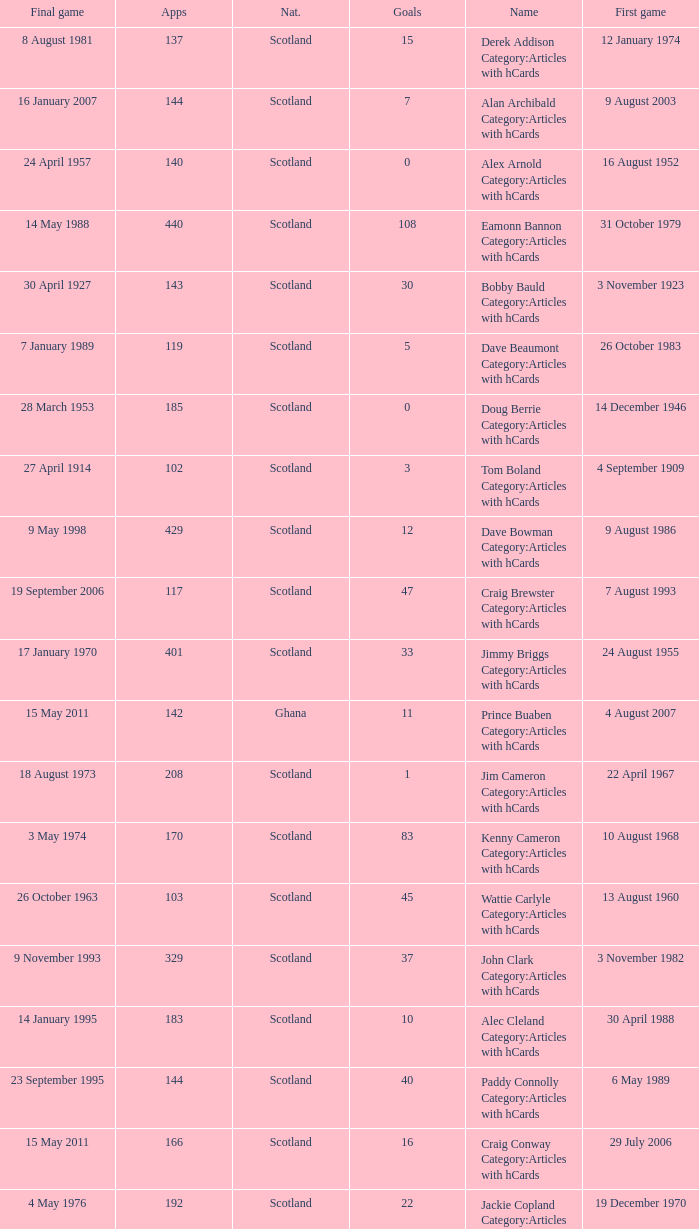What name has 118 as the apps? Ron Yeats Category:Articles with hCards. 